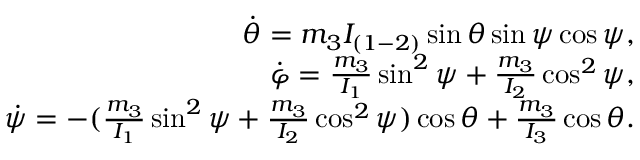Convert formula to latex. <formula><loc_0><loc_0><loc_500><loc_500>\begin{array} { r } { \dot { \theta } = m _ { 3 } I _ { ( 1 - 2 ) } \sin \theta \sin \psi \cos \psi , } \\ { \dot { \varphi } = \frac { m _ { 3 } } { I _ { 1 } } \sin ^ { 2 } \psi + \frac { m _ { 3 } } { I _ { 2 } } \cos ^ { 2 } \psi , } \\ { \dot { \psi } = - ( \frac { m _ { 3 } } { I _ { 1 } } \sin ^ { 2 } \psi + \frac { m _ { 3 } } { I _ { 2 } } \cos ^ { 2 } \psi ) \cos \theta + \frac { m _ { 3 } } { I _ { 3 } } \cos \theta . } \end{array}</formula> 